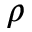Convert formula to latex. <formula><loc_0><loc_0><loc_500><loc_500>\rho</formula> 